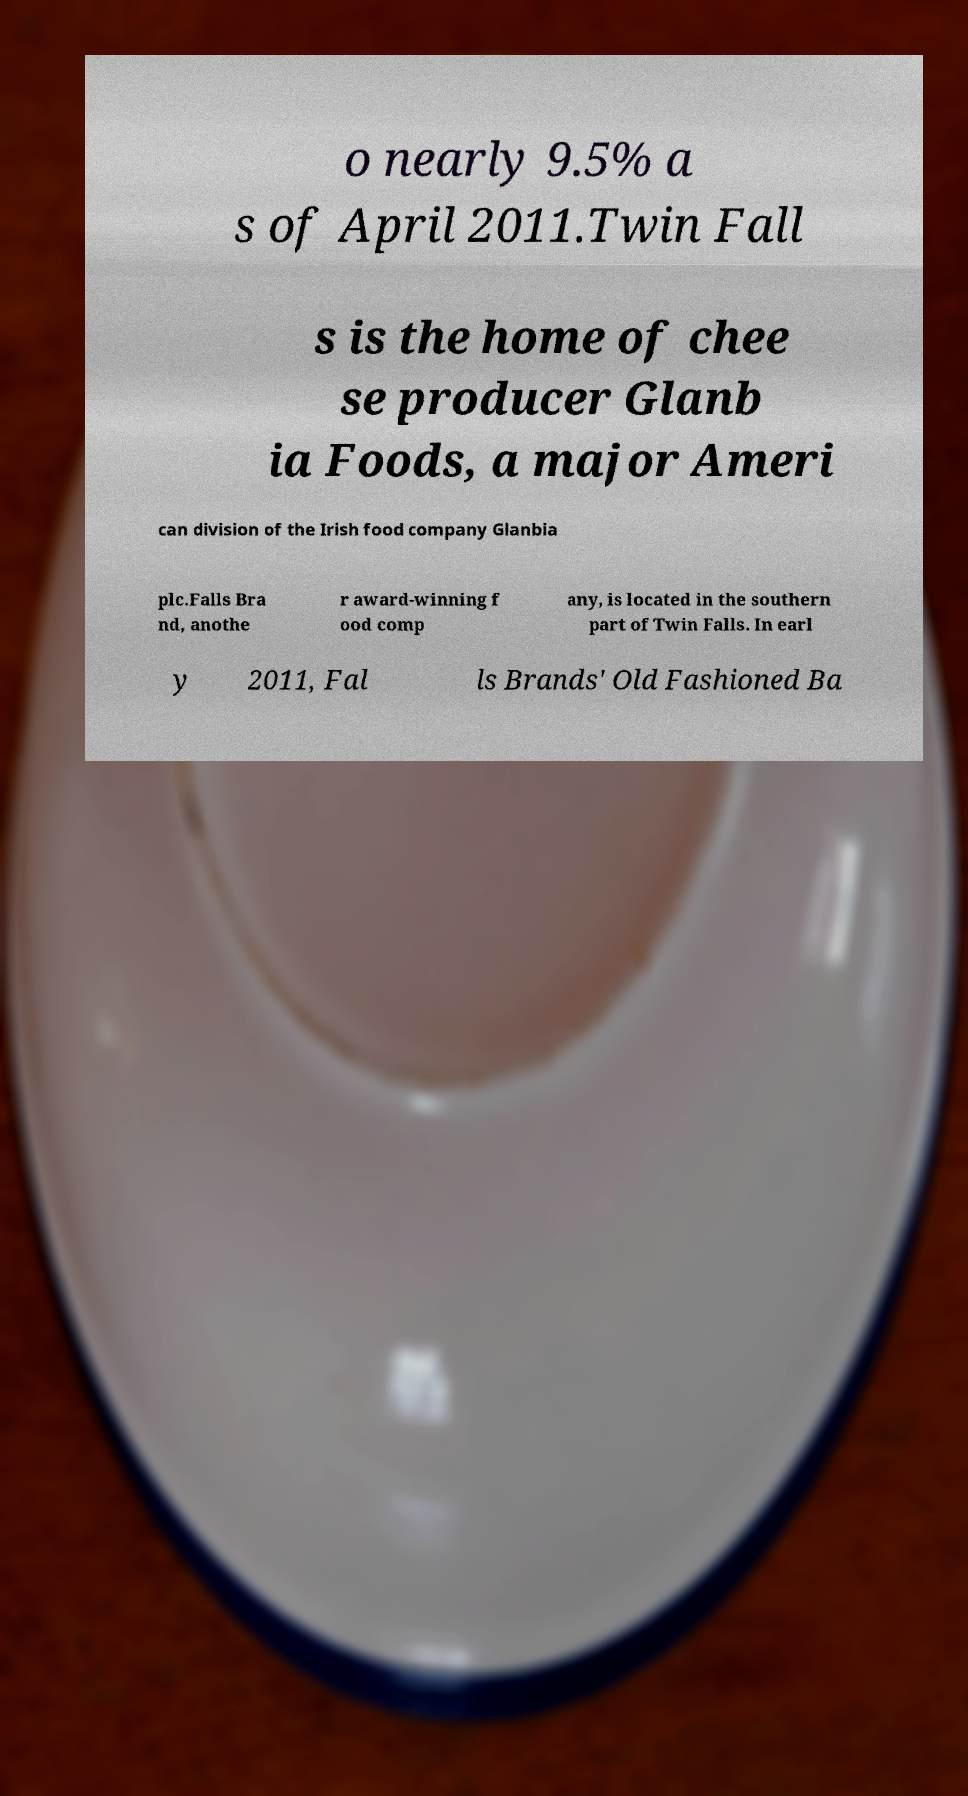There's text embedded in this image that I need extracted. Can you transcribe it verbatim? o nearly 9.5% a s of April 2011.Twin Fall s is the home of chee se producer Glanb ia Foods, a major Ameri can division of the Irish food company Glanbia plc.Falls Bra nd, anothe r award-winning f ood comp any, is located in the southern part of Twin Falls. In earl y 2011, Fal ls Brands' Old Fashioned Ba 